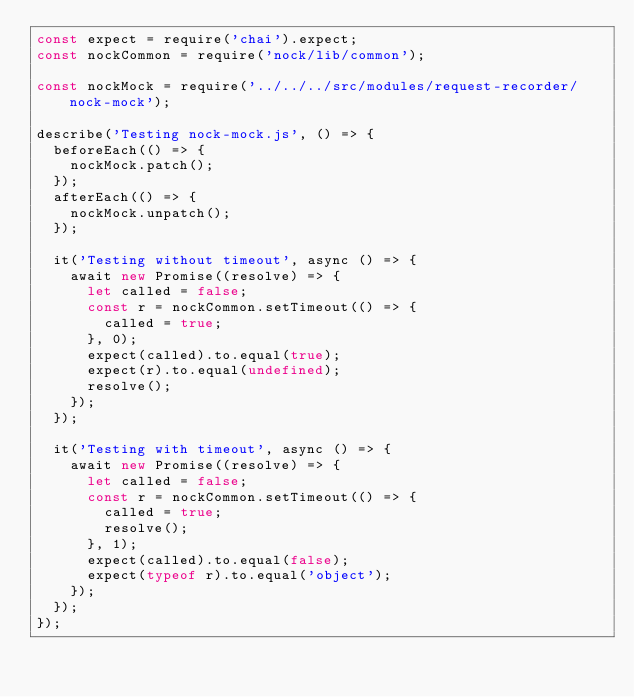<code> <loc_0><loc_0><loc_500><loc_500><_JavaScript_>const expect = require('chai').expect;
const nockCommon = require('nock/lib/common');

const nockMock = require('../../../src/modules/request-recorder/nock-mock');

describe('Testing nock-mock.js', () => {
  beforeEach(() => {
    nockMock.patch();
  });
  afterEach(() => {
    nockMock.unpatch();
  });

  it('Testing without timeout', async () => {
    await new Promise((resolve) => {
      let called = false;
      const r = nockCommon.setTimeout(() => {
        called = true;
      }, 0);
      expect(called).to.equal(true);
      expect(r).to.equal(undefined);
      resolve();
    });
  });

  it('Testing with timeout', async () => {
    await new Promise((resolve) => {
      let called = false;
      const r = nockCommon.setTimeout(() => {
        called = true;
        resolve();
      }, 1);
      expect(called).to.equal(false);
      expect(typeof r).to.equal('object');
    });
  });
});
</code> 